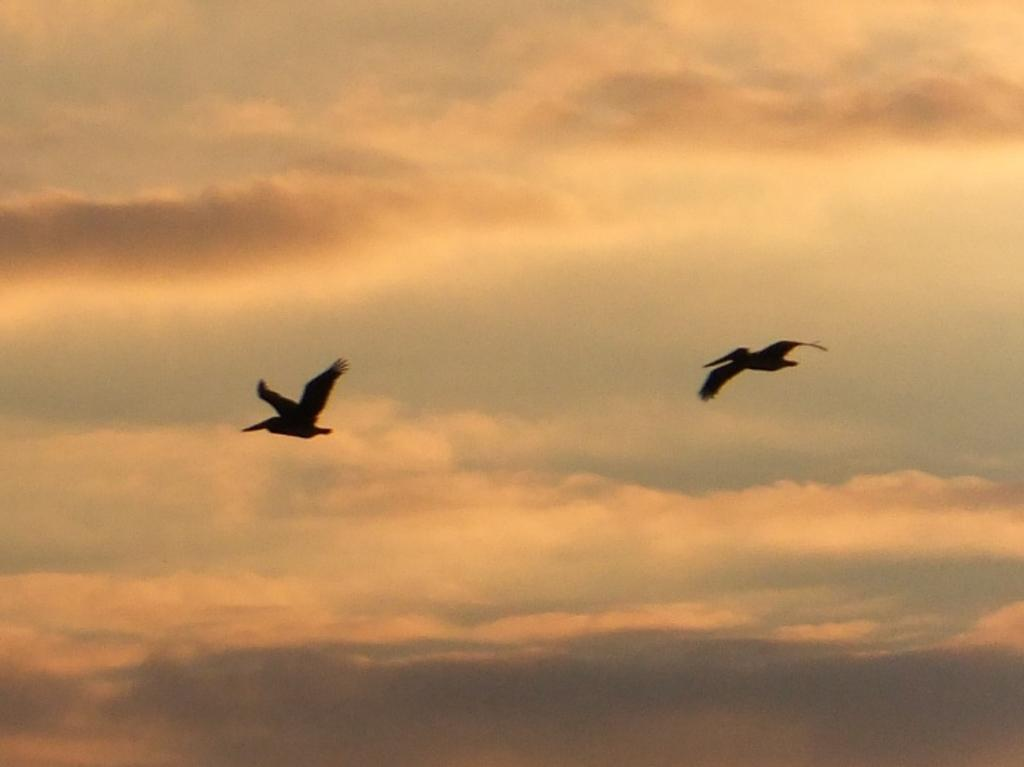How many birds are present in the image? There are two birds in the image. What are the birds doing in the image? The birds are flying in the air. What can be seen in the background of the image? The sky is visible in the background of the image. What type of question is being asked by the bird on the left side of the image? There is no indication in the image that the birds are asking any questions, as they are simply flying in the air. 